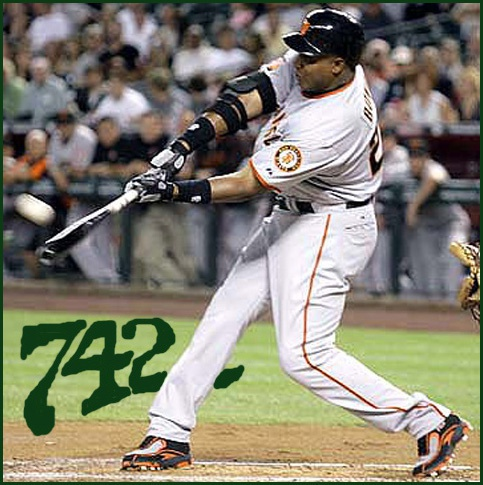Describe the objects in this image and their specific colors. I can see people in darkgreen, lavender, black, darkgray, and gray tones, people in darkgreen, gray, black, and darkgray tones, people in darkgreen, gray, darkgray, and black tones, people in darkgreen, darkgray, gray, and black tones, and people in darkgreen, lavender, darkgray, and gray tones in this image. 